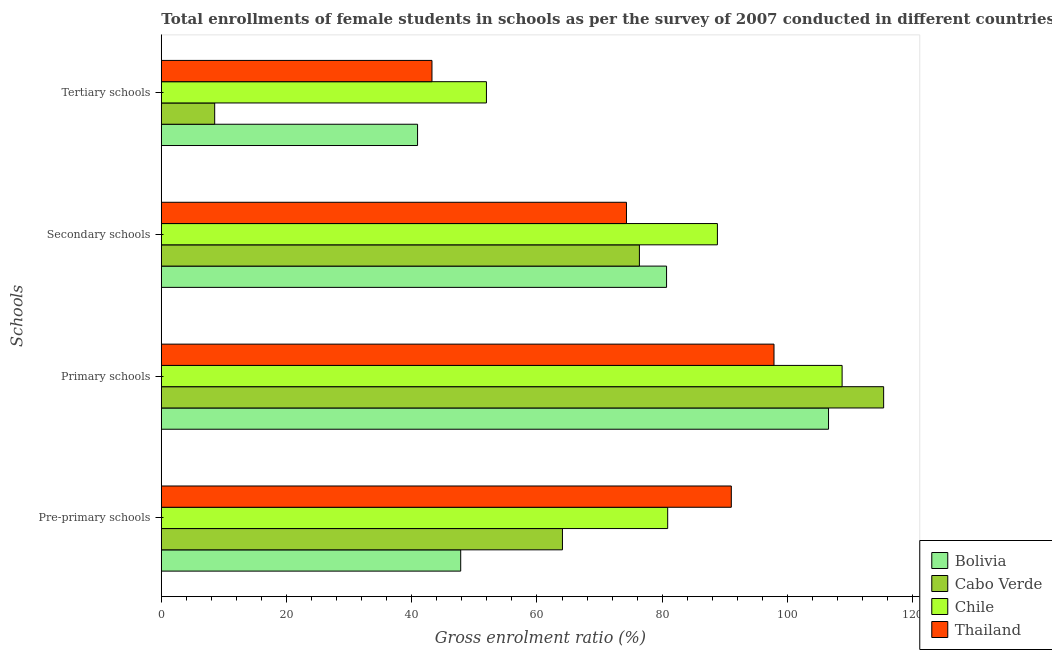How many groups of bars are there?
Your answer should be compact. 4. Are the number of bars per tick equal to the number of legend labels?
Your response must be concise. Yes. How many bars are there on the 1st tick from the top?
Keep it short and to the point. 4. How many bars are there on the 1st tick from the bottom?
Give a very brief answer. 4. What is the label of the 1st group of bars from the top?
Your answer should be very brief. Tertiary schools. What is the gross enrolment ratio(female) in secondary schools in Thailand?
Provide a succinct answer. 74.29. Across all countries, what is the maximum gross enrolment ratio(female) in pre-primary schools?
Your answer should be compact. 91.04. Across all countries, what is the minimum gross enrolment ratio(female) in primary schools?
Offer a very short reply. 97.86. In which country was the gross enrolment ratio(female) in primary schools maximum?
Give a very brief answer. Cabo Verde. What is the total gross enrolment ratio(female) in primary schools in the graph?
Your answer should be compact. 428.53. What is the difference between the gross enrolment ratio(female) in secondary schools in Thailand and that in Bolivia?
Offer a very short reply. -6.4. What is the difference between the gross enrolment ratio(female) in tertiary schools in Chile and the gross enrolment ratio(female) in pre-primary schools in Cabo Verde?
Provide a short and direct response. -12.14. What is the average gross enrolment ratio(female) in primary schools per country?
Ensure brevity in your answer.  107.13. What is the difference between the gross enrolment ratio(female) in primary schools and gross enrolment ratio(female) in pre-primary schools in Bolivia?
Offer a very short reply. 58.75. In how many countries, is the gross enrolment ratio(female) in primary schools greater than 8 %?
Your answer should be very brief. 4. What is the ratio of the gross enrolment ratio(female) in pre-primary schools in Thailand to that in Bolivia?
Give a very brief answer. 1.9. Is the gross enrolment ratio(female) in pre-primary schools in Chile less than that in Thailand?
Make the answer very short. Yes. What is the difference between the highest and the second highest gross enrolment ratio(female) in primary schools?
Offer a terse response. 6.63. What is the difference between the highest and the lowest gross enrolment ratio(female) in tertiary schools?
Give a very brief answer. 43.4. Is the sum of the gross enrolment ratio(female) in tertiary schools in Cabo Verde and Bolivia greater than the maximum gross enrolment ratio(female) in pre-primary schools across all countries?
Offer a terse response. No. What does the 1st bar from the top in Secondary schools represents?
Give a very brief answer. Thailand. What does the 3rd bar from the bottom in Tertiary schools represents?
Give a very brief answer. Chile. How many bars are there?
Offer a terse response. 16. Does the graph contain grids?
Ensure brevity in your answer.  No. Where does the legend appear in the graph?
Your answer should be compact. Bottom right. How are the legend labels stacked?
Provide a short and direct response. Vertical. What is the title of the graph?
Ensure brevity in your answer.  Total enrollments of female students in schools as per the survey of 2007 conducted in different countries. What is the label or title of the Y-axis?
Keep it short and to the point. Schools. What is the Gross enrolment ratio (%) of Bolivia in Pre-primary schools?
Your answer should be compact. 47.82. What is the Gross enrolment ratio (%) of Cabo Verde in Pre-primary schools?
Ensure brevity in your answer.  64.07. What is the Gross enrolment ratio (%) in Chile in Pre-primary schools?
Your response must be concise. 80.88. What is the Gross enrolment ratio (%) in Thailand in Pre-primary schools?
Keep it short and to the point. 91.04. What is the Gross enrolment ratio (%) of Bolivia in Primary schools?
Your answer should be compact. 106.57. What is the Gross enrolment ratio (%) of Cabo Verde in Primary schools?
Provide a short and direct response. 115.37. What is the Gross enrolment ratio (%) of Chile in Primary schools?
Your response must be concise. 108.74. What is the Gross enrolment ratio (%) in Thailand in Primary schools?
Provide a short and direct response. 97.86. What is the Gross enrolment ratio (%) in Bolivia in Secondary schools?
Make the answer very short. 80.7. What is the Gross enrolment ratio (%) in Cabo Verde in Secondary schools?
Your response must be concise. 76.36. What is the Gross enrolment ratio (%) in Chile in Secondary schools?
Provide a succinct answer. 88.82. What is the Gross enrolment ratio (%) of Thailand in Secondary schools?
Ensure brevity in your answer.  74.29. What is the Gross enrolment ratio (%) of Bolivia in Tertiary schools?
Your answer should be very brief. 40.93. What is the Gross enrolment ratio (%) in Cabo Verde in Tertiary schools?
Provide a succinct answer. 8.53. What is the Gross enrolment ratio (%) in Chile in Tertiary schools?
Give a very brief answer. 51.93. What is the Gross enrolment ratio (%) of Thailand in Tertiary schools?
Your response must be concise. 43.23. Across all Schools, what is the maximum Gross enrolment ratio (%) in Bolivia?
Your response must be concise. 106.57. Across all Schools, what is the maximum Gross enrolment ratio (%) of Cabo Verde?
Offer a very short reply. 115.37. Across all Schools, what is the maximum Gross enrolment ratio (%) of Chile?
Offer a terse response. 108.74. Across all Schools, what is the maximum Gross enrolment ratio (%) of Thailand?
Your response must be concise. 97.86. Across all Schools, what is the minimum Gross enrolment ratio (%) in Bolivia?
Provide a succinct answer. 40.93. Across all Schools, what is the minimum Gross enrolment ratio (%) in Cabo Verde?
Keep it short and to the point. 8.53. Across all Schools, what is the minimum Gross enrolment ratio (%) of Chile?
Your response must be concise. 51.93. Across all Schools, what is the minimum Gross enrolment ratio (%) of Thailand?
Provide a succinct answer. 43.23. What is the total Gross enrolment ratio (%) of Bolivia in the graph?
Offer a very short reply. 276.01. What is the total Gross enrolment ratio (%) in Cabo Verde in the graph?
Offer a very short reply. 264.32. What is the total Gross enrolment ratio (%) of Chile in the graph?
Offer a very short reply. 330.36. What is the total Gross enrolment ratio (%) of Thailand in the graph?
Provide a short and direct response. 306.42. What is the difference between the Gross enrolment ratio (%) in Bolivia in Pre-primary schools and that in Primary schools?
Ensure brevity in your answer.  -58.75. What is the difference between the Gross enrolment ratio (%) of Cabo Verde in Pre-primary schools and that in Primary schools?
Provide a short and direct response. -51.3. What is the difference between the Gross enrolment ratio (%) of Chile in Pre-primary schools and that in Primary schools?
Make the answer very short. -27.86. What is the difference between the Gross enrolment ratio (%) in Thailand in Pre-primary schools and that in Primary schools?
Your response must be concise. -6.82. What is the difference between the Gross enrolment ratio (%) in Bolivia in Pre-primary schools and that in Secondary schools?
Provide a short and direct response. -32.88. What is the difference between the Gross enrolment ratio (%) of Cabo Verde in Pre-primary schools and that in Secondary schools?
Ensure brevity in your answer.  -12.29. What is the difference between the Gross enrolment ratio (%) of Chile in Pre-primary schools and that in Secondary schools?
Offer a very short reply. -7.94. What is the difference between the Gross enrolment ratio (%) in Thailand in Pre-primary schools and that in Secondary schools?
Ensure brevity in your answer.  16.74. What is the difference between the Gross enrolment ratio (%) of Bolivia in Pre-primary schools and that in Tertiary schools?
Your answer should be compact. 6.89. What is the difference between the Gross enrolment ratio (%) of Cabo Verde in Pre-primary schools and that in Tertiary schools?
Offer a very short reply. 55.54. What is the difference between the Gross enrolment ratio (%) of Chile in Pre-primary schools and that in Tertiary schools?
Make the answer very short. 28.95. What is the difference between the Gross enrolment ratio (%) of Thailand in Pre-primary schools and that in Tertiary schools?
Give a very brief answer. 47.81. What is the difference between the Gross enrolment ratio (%) in Bolivia in Primary schools and that in Secondary schools?
Your answer should be very brief. 25.87. What is the difference between the Gross enrolment ratio (%) of Cabo Verde in Primary schools and that in Secondary schools?
Keep it short and to the point. 39.01. What is the difference between the Gross enrolment ratio (%) of Chile in Primary schools and that in Secondary schools?
Keep it short and to the point. 19.92. What is the difference between the Gross enrolment ratio (%) of Thailand in Primary schools and that in Secondary schools?
Your answer should be compact. 23.56. What is the difference between the Gross enrolment ratio (%) of Bolivia in Primary schools and that in Tertiary schools?
Your answer should be very brief. 65.64. What is the difference between the Gross enrolment ratio (%) in Cabo Verde in Primary schools and that in Tertiary schools?
Ensure brevity in your answer.  106.84. What is the difference between the Gross enrolment ratio (%) in Chile in Primary schools and that in Tertiary schools?
Provide a short and direct response. 56.81. What is the difference between the Gross enrolment ratio (%) of Thailand in Primary schools and that in Tertiary schools?
Your answer should be very brief. 54.63. What is the difference between the Gross enrolment ratio (%) in Bolivia in Secondary schools and that in Tertiary schools?
Offer a very short reply. 39.77. What is the difference between the Gross enrolment ratio (%) of Cabo Verde in Secondary schools and that in Tertiary schools?
Offer a terse response. 67.83. What is the difference between the Gross enrolment ratio (%) in Chile in Secondary schools and that in Tertiary schools?
Make the answer very short. 36.89. What is the difference between the Gross enrolment ratio (%) of Thailand in Secondary schools and that in Tertiary schools?
Offer a terse response. 31.07. What is the difference between the Gross enrolment ratio (%) in Bolivia in Pre-primary schools and the Gross enrolment ratio (%) in Cabo Verde in Primary schools?
Make the answer very short. -67.55. What is the difference between the Gross enrolment ratio (%) in Bolivia in Pre-primary schools and the Gross enrolment ratio (%) in Chile in Primary schools?
Provide a succinct answer. -60.92. What is the difference between the Gross enrolment ratio (%) of Bolivia in Pre-primary schools and the Gross enrolment ratio (%) of Thailand in Primary schools?
Make the answer very short. -50.04. What is the difference between the Gross enrolment ratio (%) in Cabo Verde in Pre-primary schools and the Gross enrolment ratio (%) in Chile in Primary schools?
Make the answer very short. -44.67. What is the difference between the Gross enrolment ratio (%) in Cabo Verde in Pre-primary schools and the Gross enrolment ratio (%) in Thailand in Primary schools?
Give a very brief answer. -33.79. What is the difference between the Gross enrolment ratio (%) in Chile in Pre-primary schools and the Gross enrolment ratio (%) in Thailand in Primary schools?
Your answer should be compact. -16.98. What is the difference between the Gross enrolment ratio (%) in Bolivia in Pre-primary schools and the Gross enrolment ratio (%) in Cabo Verde in Secondary schools?
Offer a very short reply. -28.54. What is the difference between the Gross enrolment ratio (%) in Bolivia in Pre-primary schools and the Gross enrolment ratio (%) in Chile in Secondary schools?
Provide a short and direct response. -41. What is the difference between the Gross enrolment ratio (%) in Bolivia in Pre-primary schools and the Gross enrolment ratio (%) in Thailand in Secondary schools?
Offer a very short reply. -26.48. What is the difference between the Gross enrolment ratio (%) of Cabo Verde in Pre-primary schools and the Gross enrolment ratio (%) of Chile in Secondary schools?
Keep it short and to the point. -24.75. What is the difference between the Gross enrolment ratio (%) in Cabo Verde in Pre-primary schools and the Gross enrolment ratio (%) in Thailand in Secondary schools?
Offer a very short reply. -10.23. What is the difference between the Gross enrolment ratio (%) of Chile in Pre-primary schools and the Gross enrolment ratio (%) of Thailand in Secondary schools?
Offer a very short reply. 6.58. What is the difference between the Gross enrolment ratio (%) of Bolivia in Pre-primary schools and the Gross enrolment ratio (%) of Cabo Verde in Tertiary schools?
Make the answer very short. 39.29. What is the difference between the Gross enrolment ratio (%) in Bolivia in Pre-primary schools and the Gross enrolment ratio (%) in Chile in Tertiary schools?
Provide a succinct answer. -4.11. What is the difference between the Gross enrolment ratio (%) in Bolivia in Pre-primary schools and the Gross enrolment ratio (%) in Thailand in Tertiary schools?
Provide a short and direct response. 4.59. What is the difference between the Gross enrolment ratio (%) of Cabo Verde in Pre-primary schools and the Gross enrolment ratio (%) of Chile in Tertiary schools?
Keep it short and to the point. 12.14. What is the difference between the Gross enrolment ratio (%) of Cabo Verde in Pre-primary schools and the Gross enrolment ratio (%) of Thailand in Tertiary schools?
Keep it short and to the point. 20.84. What is the difference between the Gross enrolment ratio (%) in Chile in Pre-primary schools and the Gross enrolment ratio (%) in Thailand in Tertiary schools?
Make the answer very short. 37.65. What is the difference between the Gross enrolment ratio (%) in Bolivia in Primary schools and the Gross enrolment ratio (%) in Cabo Verde in Secondary schools?
Ensure brevity in your answer.  30.21. What is the difference between the Gross enrolment ratio (%) of Bolivia in Primary schools and the Gross enrolment ratio (%) of Chile in Secondary schools?
Provide a short and direct response. 17.75. What is the difference between the Gross enrolment ratio (%) of Bolivia in Primary schools and the Gross enrolment ratio (%) of Thailand in Secondary schools?
Your answer should be very brief. 32.27. What is the difference between the Gross enrolment ratio (%) of Cabo Verde in Primary schools and the Gross enrolment ratio (%) of Chile in Secondary schools?
Offer a terse response. 26.55. What is the difference between the Gross enrolment ratio (%) in Cabo Verde in Primary schools and the Gross enrolment ratio (%) in Thailand in Secondary schools?
Make the answer very short. 41.07. What is the difference between the Gross enrolment ratio (%) of Chile in Primary schools and the Gross enrolment ratio (%) of Thailand in Secondary schools?
Make the answer very short. 34.44. What is the difference between the Gross enrolment ratio (%) in Bolivia in Primary schools and the Gross enrolment ratio (%) in Cabo Verde in Tertiary schools?
Offer a very short reply. 98.04. What is the difference between the Gross enrolment ratio (%) of Bolivia in Primary schools and the Gross enrolment ratio (%) of Chile in Tertiary schools?
Your response must be concise. 54.64. What is the difference between the Gross enrolment ratio (%) in Bolivia in Primary schools and the Gross enrolment ratio (%) in Thailand in Tertiary schools?
Your answer should be very brief. 63.34. What is the difference between the Gross enrolment ratio (%) of Cabo Verde in Primary schools and the Gross enrolment ratio (%) of Chile in Tertiary schools?
Give a very brief answer. 63.44. What is the difference between the Gross enrolment ratio (%) in Cabo Verde in Primary schools and the Gross enrolment ratio (%) in Thailand in Tertiary schools?
Keep it short and to the point. 72.14. What is the difference between the Gross enrolment ratio (%) of Chile in Primary schools and the Gross enrolment ratio (%) of Thailand in Tertiary schools?
Make the answer very short. 65.51. What is the difference between the Gross enrolment ratio (%) of Bolivia in Secondary schools and the Gross enrolment ratio (%) of Cabo Verde in Tertiary schools?
Offer a terse response. 72.17. What is the difference between the Gross enrolment ratio (%) in Bolivia in Secondary schools and the Gross enrolment ratio (%) in Chile in Tertiary schools?
Provide a succinct answer. 28.77. What is the difference between the Gross enrolment ratio (%) in Bolivia in Secondary schools and the Gross enrolment ratio (%) in Thailand in Tertiary schools?
Your answer should be compact. 37.47. What is the difference between the Gross enrolment ratio (%) of Cabo Verde in Secondary schools and the Gross enrolment ratio (%) of Chile in Tertiary schools?
Offer a very short reply. 24.43. What is the difference between the Gross enrolment ratio (%) in Cabo Verde in Secondary schools and the Gross enrolment ratio (%) in Thailand in Tertiary schools?
Offer a terse response. 33.13. What is the difference between the Gross enrolment ratio (%) in Chile in Secondary schools and the Gross enrolment ratio (%) in Thailand in Tertiary schools?
Offer a terse response. 45.59. What is the average Gross enrolment ratio (%) in Bolivia per Schools?
Keep it short and to the point. 69. What is the average Gross enrolment ratio (%) in Cabo Verde per Schools?
Your answer should be very brief. 66.08. What is the average Gross enrolment ratio (%) of Chile per Schools?
Offer a terse response. 82.59. What is the average Gross enrolment ratio (%) of Thailand per Schools?
Make the answer very short. 76.6. What is the difference between the Gross enrolment ratio (%) of Bolivia and Gross enrolment ratio (%) of Cabo Verde in Pre-primary schools?
Offer a terse response. -16.25. What is the difference between the Gross enrolment ratio (%) in Bolivia and Gross enrolment ratio (%) in Chile in Pre-primary schools?
Your response must be concise. -33.06. What is the difference between the Gross enrolment ratio (%) of Bolivia and Gross enrolment ratio (%) of Thailand in Pre-primary schools?
Give a very brief answer. -43.22. What is the difference between the Gross enrolment ratio (%) of Cabo Verde and Gross enrolment ratio (%) of Chile in Pre-primary schools?
Your response must be concise. -16.81. What is the difference between the Gross enrolment ratio (%) of Cabo Verde and Gross enrolment ratio (%) of Thailand in Pre-primary schools?
Keep it short and to the point. -26.97. What is the difference between the Gross enrolment ratio (%) of Chile and Gross enrolment ratio (%) of Thailand in Pre-primary schools?
Make the answer very short. -10.16. What is the difference between the Gross enrolment ratio (%) in Bolivia and Gross enrolment ratio (%) in Cabo Verde in Primary schools?
Provide a short and direct response. -8.8. What is the difference between the Gross enrolment ratio (%) in Bolivia and Gross enrolment ratio (%) in Chile in Primary schools?
Offer a very short reply. -2.17. What is the difference between the Gross enrolment ratio (%) in Bolivia and Gross enrolment ratio (%) in Thailand in Primary schools?
Provide a succinct answer. 8.71. What is the difference between the Gross enrolment ratio (%) of Cabo Verde and Gross enrolment ratio (%) of Chile in Primary schools?
Ensure brevity in your answer.  6.63. What is the difference between the Gross enrolment ratio (%) of Cabo Verde and Gross enrolment ratio (%) of Thailand in Primary schools?
Provide a short and direct response. 17.51. What is the difference between the Gross enrolment ratio (%) of Chile and Gross enrolment ratio (%) of Thailand in Primary schools?
Your response must be concise. 10.88. What is the difference between the Gross enrolment ratio (%) of Bolivia and Gross enrolment ratio (%) of Cabo Verde in Secondary schools?
Give a very brief answer. 4.34. What is the difference between the Gross enrolment ratio (%) in Bolivia and Gross enrolment ratio (%) in Chile in Secondary schools?
Ensure brevity in your answer.  -8.12. What is the difference between the Gross enrolment ratio (%) in Bolivia and Gross enrolment ratio (%) in Thailand in Secondary schools?
Provide a short and direct response. 6.4. What is the difference between the Gross enrolment ratio (%) of Cabo Verde and Gross enrolment ratio (%) of Chile in Secondary schools?
Keep it short and to the point. -12.46. What is the difference between the Gross enrolment ratio (%) in Cabo Verde and Gross enrolment ratio (%) in Thailand in Secondary schools?
Your response must be concise. 2.07. What is the difference between the Gross enrolment ratio (%) of Chile and Gross enrolment ratio (%) of Thailand in Secondary schools?
Ensure brevity in your answer.  14.52. What is the difference between the Gross enrolment ratio (%) in Bolivia and Gross enrolment ratio (%) in Cabo Verde in Tertiary schools?
Your response must be concise. 32.4. What is the difference between the Gross enrolment ratio (%) of Bolivia and Gross enrolment ratio (%) of Chile in Tertiary schools?
Offer a terse response. -11. What is the difference between the Gross enrolment ratio (%) in Bolivia and Gross enrolment ratio (%) in Thailand in Tertiary schools?
Make the answer very short. -2.3. What is the difference between the Gross enrolment ratio (%) of Cabo Verde and Gross enrolment ratio (%) of Chile in Tertiary schools?
Offer a very short reply. -43.4. What is the difference between the Gross enrolment ratio (%) in Cabo Verde and Gross enrolment ratio (%) in Thailand in Tertiary schools?
Your answer should be compact. -34.7. What is the difference between the Gross enrolment ratio (%) in Chile and Gross enrolment ratio (%) in Thailand in Tertiary schools?
Provide a short and direct response. 8.7. What is the ratio of the Gross enrolment ratio (%) of Bolivia in Pre-primary schools to that in Primary schools?
Make the answer very short. 0.45. What is the ratio of the Gross enrolment ratio (%) in Cabo Verde in Pre-primary schools to that in Primary schools?
Offer a very short reply. 0.56. What is the ratio of the Gross enrolment ratio (%) in Chile in Pre-primary schools to that in Primary schools?
Provide a short and direct response. 0.74. What is the ratio of the Gross enrolment ratio (%) of Thailand in Pre-primary schools to that in Primary schools?
Give a very brief answer. 0.93. What is the ratio of the Gross enrolment ratio (%) of Bolivia in Pre-primary schools to that in Secondary schools?
Ensure brevity in your answer.  0.59. What is the ratio of the Gross enrolment ratio (%) of Cabo Verde in Pre-primary schools to that in Secondary schools?
Offer a terse response. 0.84. What is the ratio of the Gross enrolment ratio (%) in Chile in Pre-primary schools to that in Secondary schools?
Offer a very short reply. 0.91. What is the ratio of the Gross enrolment ratio (%) in Thailand in Pre-primary schools to that in Secondary schools?
Ensure brevity in your answer.  1.23. What is the ratio of the Gross enrolment ratio (%) of Bolivia in Pre-primary schools to that in Tertiary schools?
Your response must be concise. 1.17. What is the ratio of the Gross enrolment ratio (%) in Cabo Verde in Pre-primary schools to that in Tertiary schools?
Your answer should be very brief. 7.52. What is the ratio of the Gross enrolment ratio (%) in Chile in Pre-primary schools to that in Tertiary schools?
Make the answer very short. 1.56. What is the ratio of the Gross enrolment ratio (%) of Thailand in Pre-primary schools to that in Tertiary schools?
Offer a terse response. 2.11. What is the ratio of the Gross enrolment ratio (%) in Bolivia in Primary schools to that in Secondary schools?
Keep it short and to the point. 1.32. What is the ratio of the Gross enrolment ratio (%) of Cabo Verde in Primary schools to that in Secondary schools?
Keep it short and to the point. 1.51. What is the ratio of the Gross enrolment ratio (%) in Chile in Primary schools to that in Secondary schools?
Keep it short and to the point. 1.22. What is the ratio of the Gross enrolment ratio (%) of Thailand in Primary schools to that in Secondary schools?
Keep it short and to the point. 1.32. What is the ratio of the Gross enrolment ratio (%) in Bolivia in Primary schools to that in Tertiary schools?
Your answer should be compact. 2.6. What is the ratio of the Gross enrolment ratio (%) in Cabo Verde in Primary schools to that in Tertiary schools?
Provide a succinct answer. 13.53. What is the ratio of the Gross enrolment ratio (%) of Chile in Primary schools to that in Tertiary schools?
Provide a succinct answer. 2.09. What is the ratio of the Gross enrolment ratio (%) of Thailand in Primary schools to that in Tertiary schools?
Offer a terse response. 2.26. What is the ratio of the Gross enrolment ratio (%) in Bolivia in Secondary schools to that in Tertiary schools?
Make the answer very short. 1.97. What is the ratio of the Gross enrolment ratio (%) of Cabo Verde in Secondary schools to that in Tertiary schools?
Offer a terse response. 8.96. What is the ratio of the Gross enrolment ratio (%) of Chile in Secondary schools to that in Tertiary schools?
Your response must be concise. 1.71. What is the ratio of the Gross enrolment ratio (%) of Thailand in Secondary schools to that in Tertiary schools?
Your response must be concise. 1.72. What is the difference between the highest and the second highest Gross enrolment ratio (%) of Bolivia?
Offer a terse response. 25.87. What is the difference between the highest and the second highest Gross enrolment ratio (%) in Cabo Verde?
Provide a succinct answer. 39.01. What is the difference between the highest and the second highest Gross enrolment ratio (%) of Chile?
Your response must be concise. 19.92. What is the difference between the highest and the second highest Gross enrolment ratio (%) in Thailand?
Provide a short and direct response. 6.82. What is the difference between the highest and the lowest Gross enrolment ratio (%) of Bolivia?
Give a very brief answer. 65.64. What is the difference between the highest and the lowest Gross enrolment ratio (%) of Cabo Verde?
Offer a very short reply. 106.84. What is the difference between the highest and the lowest Gross enrolment ratio (%) in Chile?
Ensure brevity in your answer.  56.81. What is the difference between the highest and the lowest Gross enrolment ratio (%) of Thailand?
Provide a succinct answer. 54.63. 